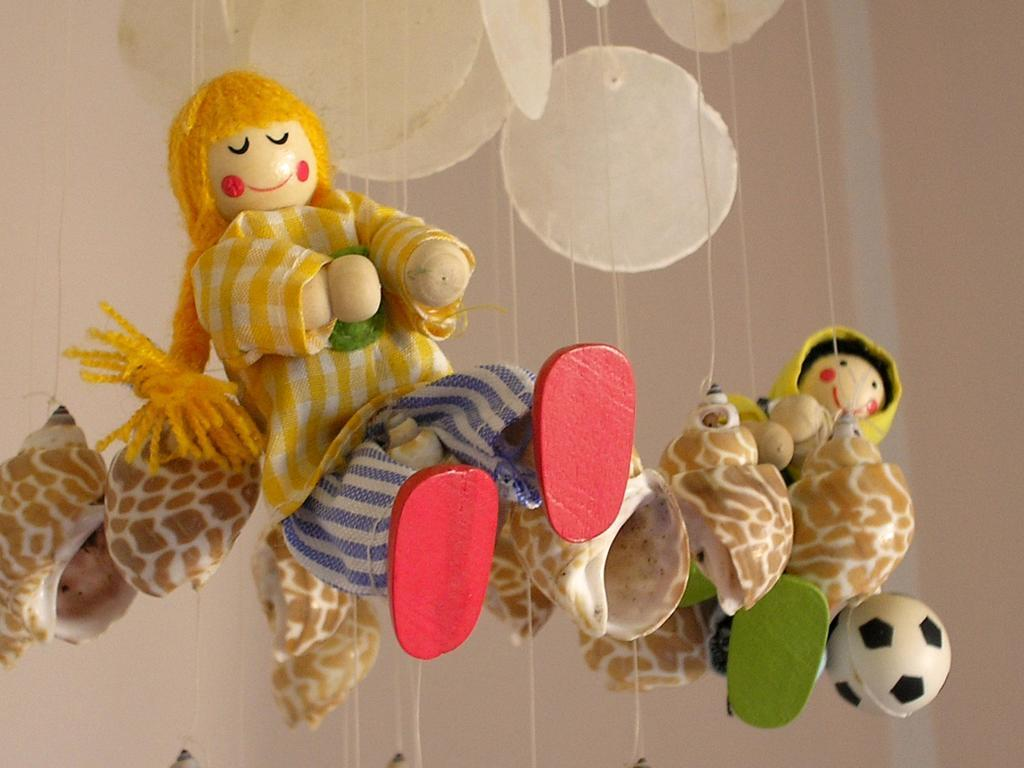What objects can be seen in the image? There are toys in the image. What else can be seen in the image besides the toys? There are threads in the image. What type of insurance is being discussed in the image? There is no discussion of insurance in the image; it features toys and threads. How does the playground in the image burst into flames? There is no playground or any indication of fire in the image; it only contains toys and threads. 